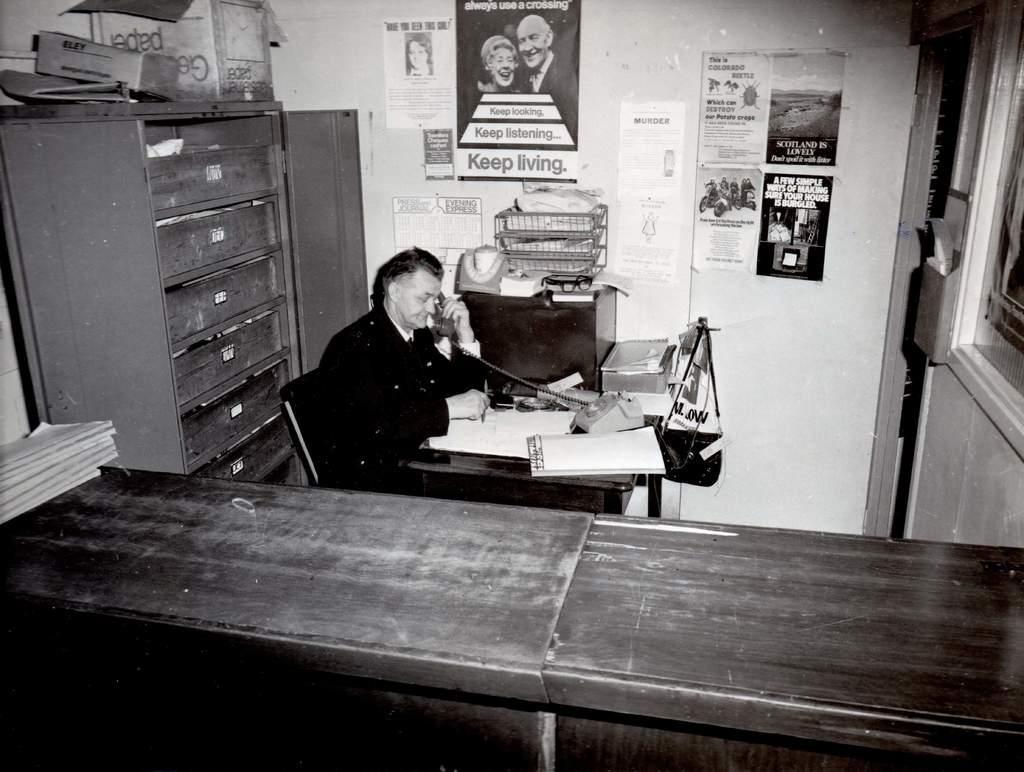In one or two sentences, can you explain what this image depicts? Here we can see a man sitting on the chair, and talking in the telephone, and in front here is the table and papers and some objects on it, and here is the wall and some pictures on it, and here is the rack. 